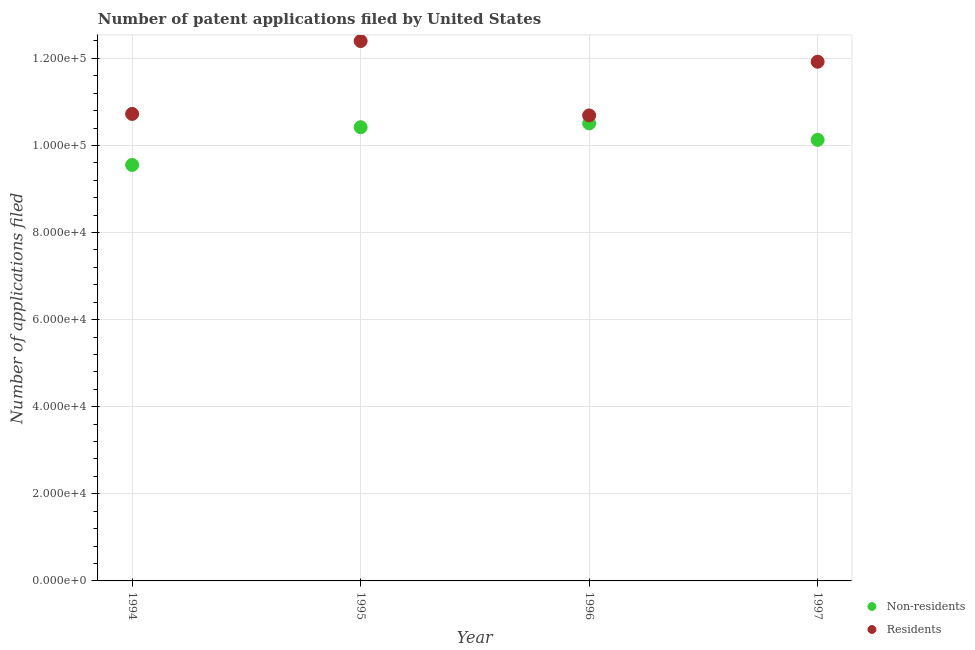How many different coloured dotlines are there?
Your answer should be very brief. 2. Is the number of dotlines equal to the number of legend labels?
Provide a succinct answer. Yes. What is the number of patent applications by non residents in 1997?
Provide a short and direct response. 1.01e+05. Across all years, what is the maximum number of patent applications by non residents?
Ensure brevity in your answer.  1.05e+05. Across all years, what is the minimum number of patent applications by residents?
Offer a terse response. 1.07e+05. In which year was the number of patent applications by residents maximum?
Offer a very short reply. 1995. In which year was the number of patent applications by residents minimum?
Your response must be concise. 1996. What is the total number of patent applications by residents in the graph?
Provide a succinct answer. 4.57e+05. What is the difference between the number of patent applications by residents in 1994 and that in 1995?
Keep it short and to the point. -1.67e+04. What is the difference between the number of patent applications by non residents in 1994 and the number of patent applications by residents in 1995?
Offer a terse response. -2.84e+04. What is the average number of patent applications by residents per year?
Your response must be concise. 1.14e+05. In the year 1995, what is the difference between the number of patent applications by non residents and number of patent applications by residents?
Provide a short and direct response. -1.98e+04. What is the ratio of the number of patent applications by non residents in 1994 to that in 1996?
Keep it short and to the point. 0.91. Is the difference between the number of patent applications by residents in 1996 and 1997 greater than the difference between the number of patent applications by non residents in 1996 and 1997?
Ensure brevity in your answer.  No. What is the difference between the highest and the second highest number of patent applications by non residents?
Provide a succinct answer. 874. What is the difference between the highest and the lowest number of patent applications by residents?
Your answer should be compact. 1.71e+04. In how many years, is the number of patent applications by residents greater than the average number of patent applications by residents taken over all years?
Your answer should be compact. 2. Does the number of patent applications by residents monotonically increase over the years?
Provide a short and direct response. No. Is the number of patent applications by residents strictly less than the number of patent applications by non residents over the years?
Your response must be concise. No. How many years are there in the graph?
Provide a short and direct response. 4. Are the values on the major ticks of Y-axis written in scientific E-notation?
Your answer should be very brief. Yes. Does the graph contain grids?
Give a very brief answer. Yes. Where does the legend appear in the graph?
Provide a short and direct response. Bottom right. What is the title of the graph?
Offer a very short reply. Number of patent applications filed by United States. Does "International Visitors" appear as one of the legend labels in the graph?
Offer a very short reply. No. What is the label or title of the X-axis?
Make the answer very short. Year. What is the label or title of the Y-axis?
Keep it short and to the point. Number of applications filed. What is the Number of applications filed of Non-residents in 1994?
Keep it short and to the point. 9.55e+04. What is the Number of applications filed of Residents in 1994?
Ensure brevity in your answer.  1.07e+05. What is the Number of applications filed of Non-residents in 1995?
Ensure brevity in your answer.  1.04e+05. What is the Number of applications filed of Residents in 1995?
Your answer should be very brief. 1.24e+05. What is the Number of applications filed of Non-residents in 1996?
Keep it short and to the point. 1.05e+05. What is the Number of applications filed of Residents in 1996?
Offer a terse response. 1.07e+05. What is the Number of applications filed in Non-residents in 1997?
Ensure brevity in your answer.  1.01e+05. What is the Number of applications filed of Residents in 1997?
Offer a very short reply. 1.19e+05. Across all years, what is the maximum Number of applications filed of Non-residents?
Offer a very short reply. 1.05e+05. Across all years, what is the maximum Number of applications filed of Residents?
Your answer should be very brief. 1.24e+05. Across all years, what is the minimum Number of applications filed in Non-residents?
Make the answer very short. 9.55e+04. Across all years, what is the minimum Number of applications filed of Residents?
Your answer should be very brief. 1.07e+05. What is the total Number of applications filed in Non-residents in the graph?
Make the answer very short. 4.06e+05. What is the total Number of applications filed in Residents in the graph?
Your answer should be very brief. 4.57e+05. What is the difference between the Number of applications filed in Non-residents in 1994 and that in 1995?
Offer a terse response. -8658. What is the difference between the Number of applications filed of Residents in 1994 and that in 1995?
Ensure brevity in your answer.  -1.67e+04. What is the difference between the Number of applications filed in Non-residents in 1994 and that in 1996?
Ensure brevity in your answer.  -9532. What is the difference between the Number of applications filed in Residents in 1994 and that in 1996?
Keep it short and to the point. 341. What is the difference between the Number of applications filed of Non-residents in 1994 and that in 1997?
Make the answer very short. -5760. What is the difference between the Number of applications filed of Residents in 1994 and that in 1997?
Your answer should be very brief. -1.20e+04. What is the difference between the Number of applications filed in Non-residents in 1995 and that in 1996?
Provide a short and direct response. -874. What is the difference between the Number of applications filed of Residents in 1995 and that in 1996?
Your response must be concise. 1.71e+04. What is the difference between the Number of applications filed in Non-residents in 1995 and that in 1997?
Ensure brevity in your answer.  2898. What is the difference between the Number of applications filed in Residents in 1995 and that in 1997?
Make the answer very short. 4748. What is the difference between the Number of applications filed in Non-residents in 1996 and that in 1997?
Offer a terse response. 3772. What is the difference between the Number of applications filed in Residents in 1996 and that in 1997?
Keep it short and to the point. -1.23e+04. What is the difference between the Number of applications filed in Non-residents in 1994 and the Number of applications filed in Residents in 1995?
Offer a very short reply. -2.84e+04. What is the difference between the Number of applications filed in Non-residents in 1994 and the Number of applications filed in Residents in 1996?
Offer a terse response. -1.14e+04. What is the difference between the Number of applications filed in Non-residents in 1994 and the Number of applications filed in Residents in 1997?
Provide a short and direct response. -2.37e+04. What is the difference between the Number of applications filed of Non-residents in 1995 and the Number of applications filed of Residents in 1996?
Make the answer very short. -2712. What is the difference between the Number of applications filed of Non-residents in 1995 and the Number of applications filed of Residents in 1997?
Keep it short and to the point. -1.50e+04. What is the difference between the Number of applications filed of Non-residents in 1996 and the Number of applications filed of Residents in 1997?
Provide a short and direct response. -1.42e+04. What is the average Number of applications filed in Non-residents per year?
Make the answer very short. 1.02e+05. What is the average Number of applications filed in Residents per year?
Offer a very short reply. 1.14e+05. In the year 1994, what is the difference between the Number of applications filed of Non-residents and Number of applications filed of Residents?
Make the answer very short. -1.17e+04. In the year 1995, what is the difference between the Number of applications filed in Non-residents and Number of applications filed in Residents?
Make the answer very short. -1.98e+04. In the year 1996, what is the difference between the Number of applications filed in Non-residents and Number of applications filed in Residents?
Make the answer very short. -1838. In the year 1997, what is the difference between the Number of applications filed of Non-residents and Number of applications filed of Residents?
Keep it short and to the point. -1.79e+04. What is the ratio of the Number of applications filed of Non-residents in 1994 to that in 1995?
Make the answer very short. 0.92. What is the ratio of the Number of applications filed of Residents in 1994 to that in 1995?
Make the answer very short. 0.86. What is the ratio of the Number of applications filed in Non-residents in 1994 to that in 1996?
Ensure brevity in your answer.  0.91. What is the ratio of the Number of applications filed of Non-residents in 1994 to that in 1997?
Your response must be concise. 0.94. What is the ratio of the Number of applications filed in Residents in 1994 to that in 1997?
Ensure brevity in your answer.  0.9. What is the ratio of the Number of applications filed of Residents in 1995 to that in 1996?
Ensure brevity in your answer.  1.16. What is the ratio of the Number of applications filed in Non-residents in 1995 to that in 1997?
Ensure brevity in your answer.  1.03. What is the ratio of the Number of applications filed in Residents in 1995 to that in 1997?
Your answer should be very brief. 1.04. What is the ratio of the Number of applications filed of Non-residents in 1996 to that in 1997?
Provide a succinct answer. 1.04. What is the ratio of the Number of applications filed of Residents in 1996 to that in 1997?
Provide a short and direct response. 0.9. What is the difference between the highest and the second highest Number of applications filed of Non-residents?
Your answer should be compact. 874. What is the difference between the highest and the second highest Number of applications filed in Residents?
Provide a succinct answer. 4748. What is the difference between the highest and the lowest Number of applications filed of Non-residents?
Your response must be concise. 9532. What is the difference between the highest and the lowest Number of applications filed of Residents?
Offer a terse response. 1.71e+04. 